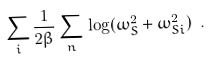<formula> <loc_0><loc_0><loc_500><loc_500>\sum _ { i } \frac { 1 } { 2 \beta } \sum _ { n } \, \log ( \omega _ { S } ^ { 2 } + \omega ^ { 2 } _ { S i } ) \ .</formula> 